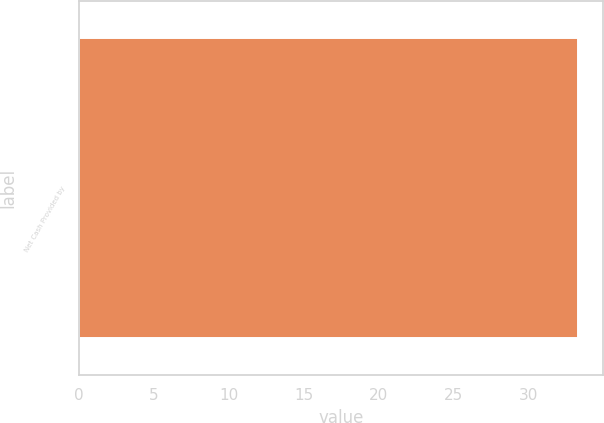<chart> <loc_0><loc_0><loc_500><loc_500><bar_chart><fcel>Net Cash Provided by<nl><fcel>33.3<nl></chart> 